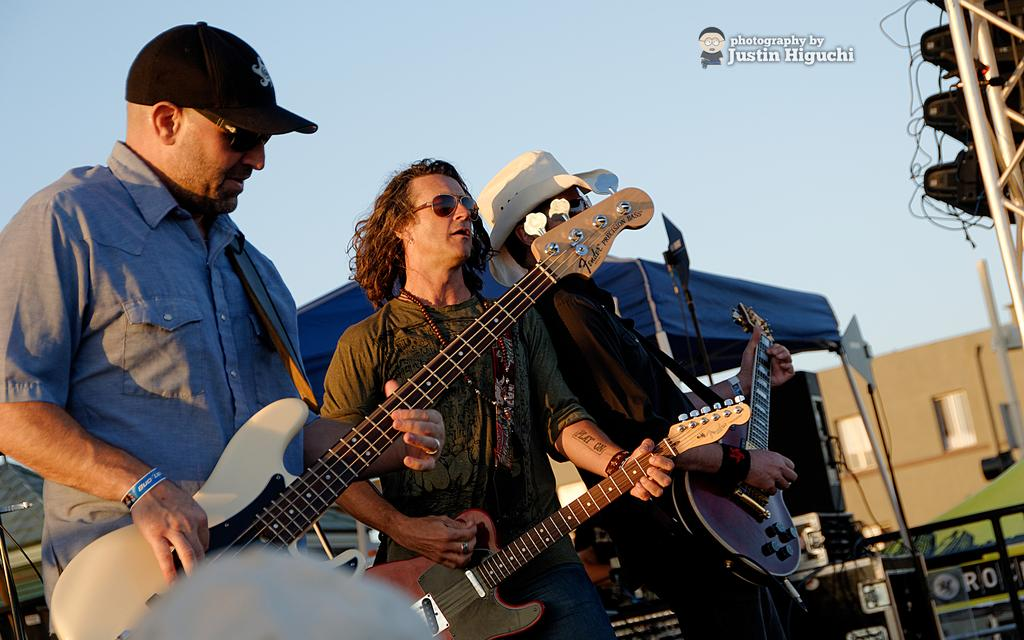How many persons are in the image? There are three persons in the image. What are the persons in the image doing? They are playing guitar. What structure can be seen in the image? There is a building in the image. What is visible at the top of the image? The sky is visible in the image. What is the name of the person holding the cheese in the image? There is no person holding cheese in the image, as the image features three persons playing guitar and no mention of cheese. 